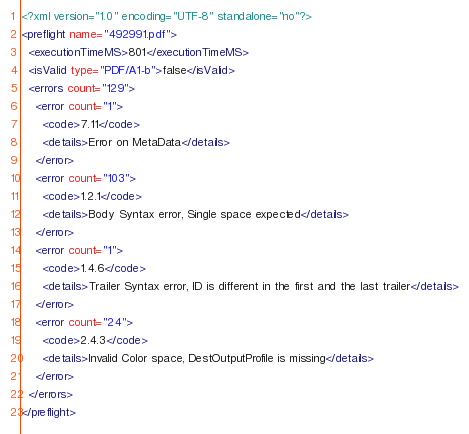<code> <loc_0><loc_0><loc_500><loc_500><_XML_><?xml version="1.0" encoding="UTF-8" standalone="no"?>
<preflight name="492991.pdf">
  <executionTimeMS>801</executionTimeMS>
  <isValid type="PDF/A1-b">false</isValid>
  <errors count="129">
    <error count="1">
      <code>7.11</code>
      <details>Error on MetaData</details>
    </error>
    <error count="103">
      <code>1.2.1</code>
      <details>Body Syntax error, Single space expected</details>
    </error>
    <error count="1">
      <code>1.4.6</code>
      <details>Trailer Syntax error, ID is different in the first and the last trailer</details>
    </error>
    <error count="24">
      <code>2.4.3</code>
      <details>Invalid Color space, DestOutputProfile is missing</details>
    </error>
  </errors>
</preflight>
</code> 